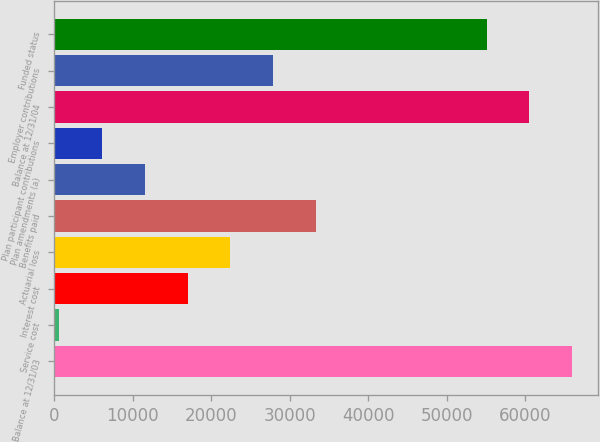Convert chart. <chart><loc_0><loc_0><loc_500><loc_500><bar_chart><fcel>Balance at 12/31/03<fcel>Service cost<fcel>Interest cost<fcel>Actuarial loss<fcel>Benefits paid<fcel>Plan amendments (a)<fcel>Plan participant contributions<fcel>Balance at 12/31/04<fcel>Employer contributions<fcel>Funded status<nl><fcel>65942<fcel>662<fcel>16982<fcel>22422<fcel>33302<fcel>11542<fcel>6102<fcel>60502<fcel>27862<fcel>55062<nl></chart> 